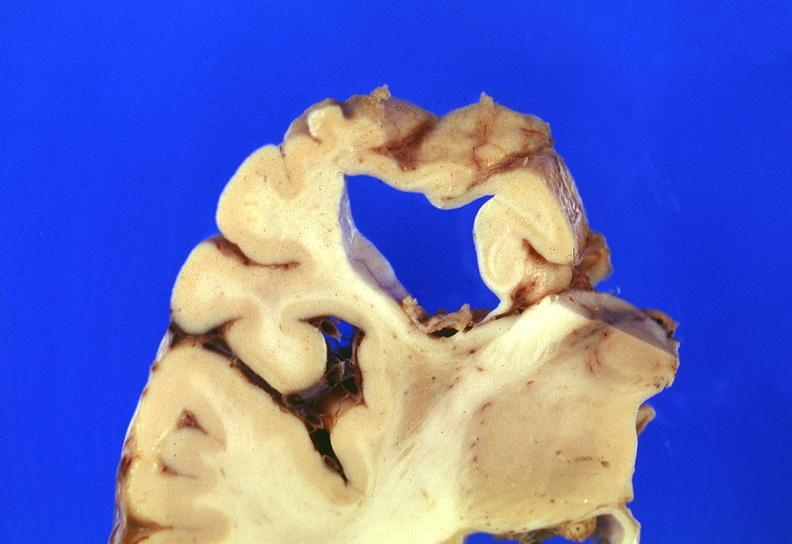what does this image show?
Answer the question using a single word or phrase. Brain 